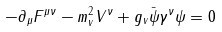<formula> <loc_0><loc_0><loc_500><loc_500>- \partial _ { \mu } F ^ { \mu \nu } - m _ { v } ^ { 2 } V ^ { \nu } + g _ { v } \bar { \psi } \gamma ^ { \nu } \psi = 0</formula> 